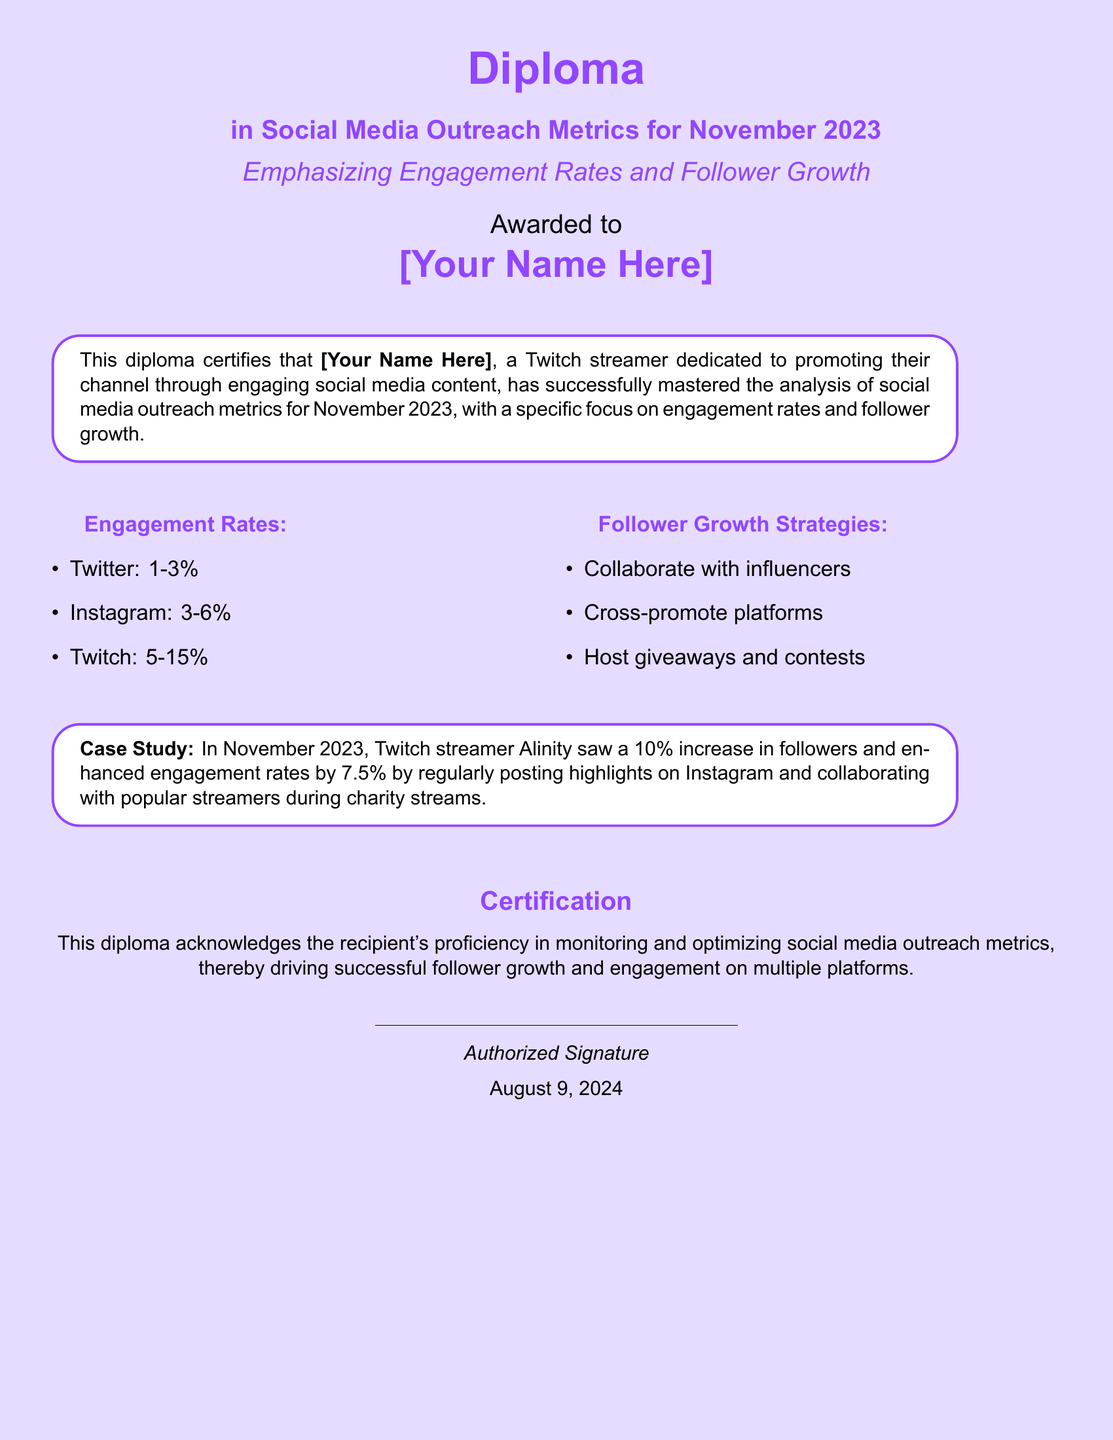What is the title of the diploma? The title of the diploma is prominently displayed at the top of the document.
Answer: Diploma in Social Media Outreach Metrics for November 2023 Who is the diploma awarded to? The recipient's name is specified in the "Awarded to" section of the document.
Answer: [Your Name Here] What is the engagement rate for Instagram? Engagement rates for different platforms are listed in the document.
Answer: 3-6% What percentage increase in followers did Alinity achieve? The case study section details follower growth statistics through a specific example.
Answer: 10% What is one strategy mentioned for follower growth? The document lists various strategies under the "Follower Growth Strategies" section.
Answer: Collaborate with influencers What is the primary focus of the diploma? The emphasis of the diploma is stated in the subtitle.
Answer: Engagement Rates and Follower Growth What are the engagement rates for Twitch? Engagement rates for different social media platforms are provided.
Answer: 5-15% What date is indicated for the signing of the diploma? The date is noted at the bottom of the document.
Answer: Today's date (the date of certification) 